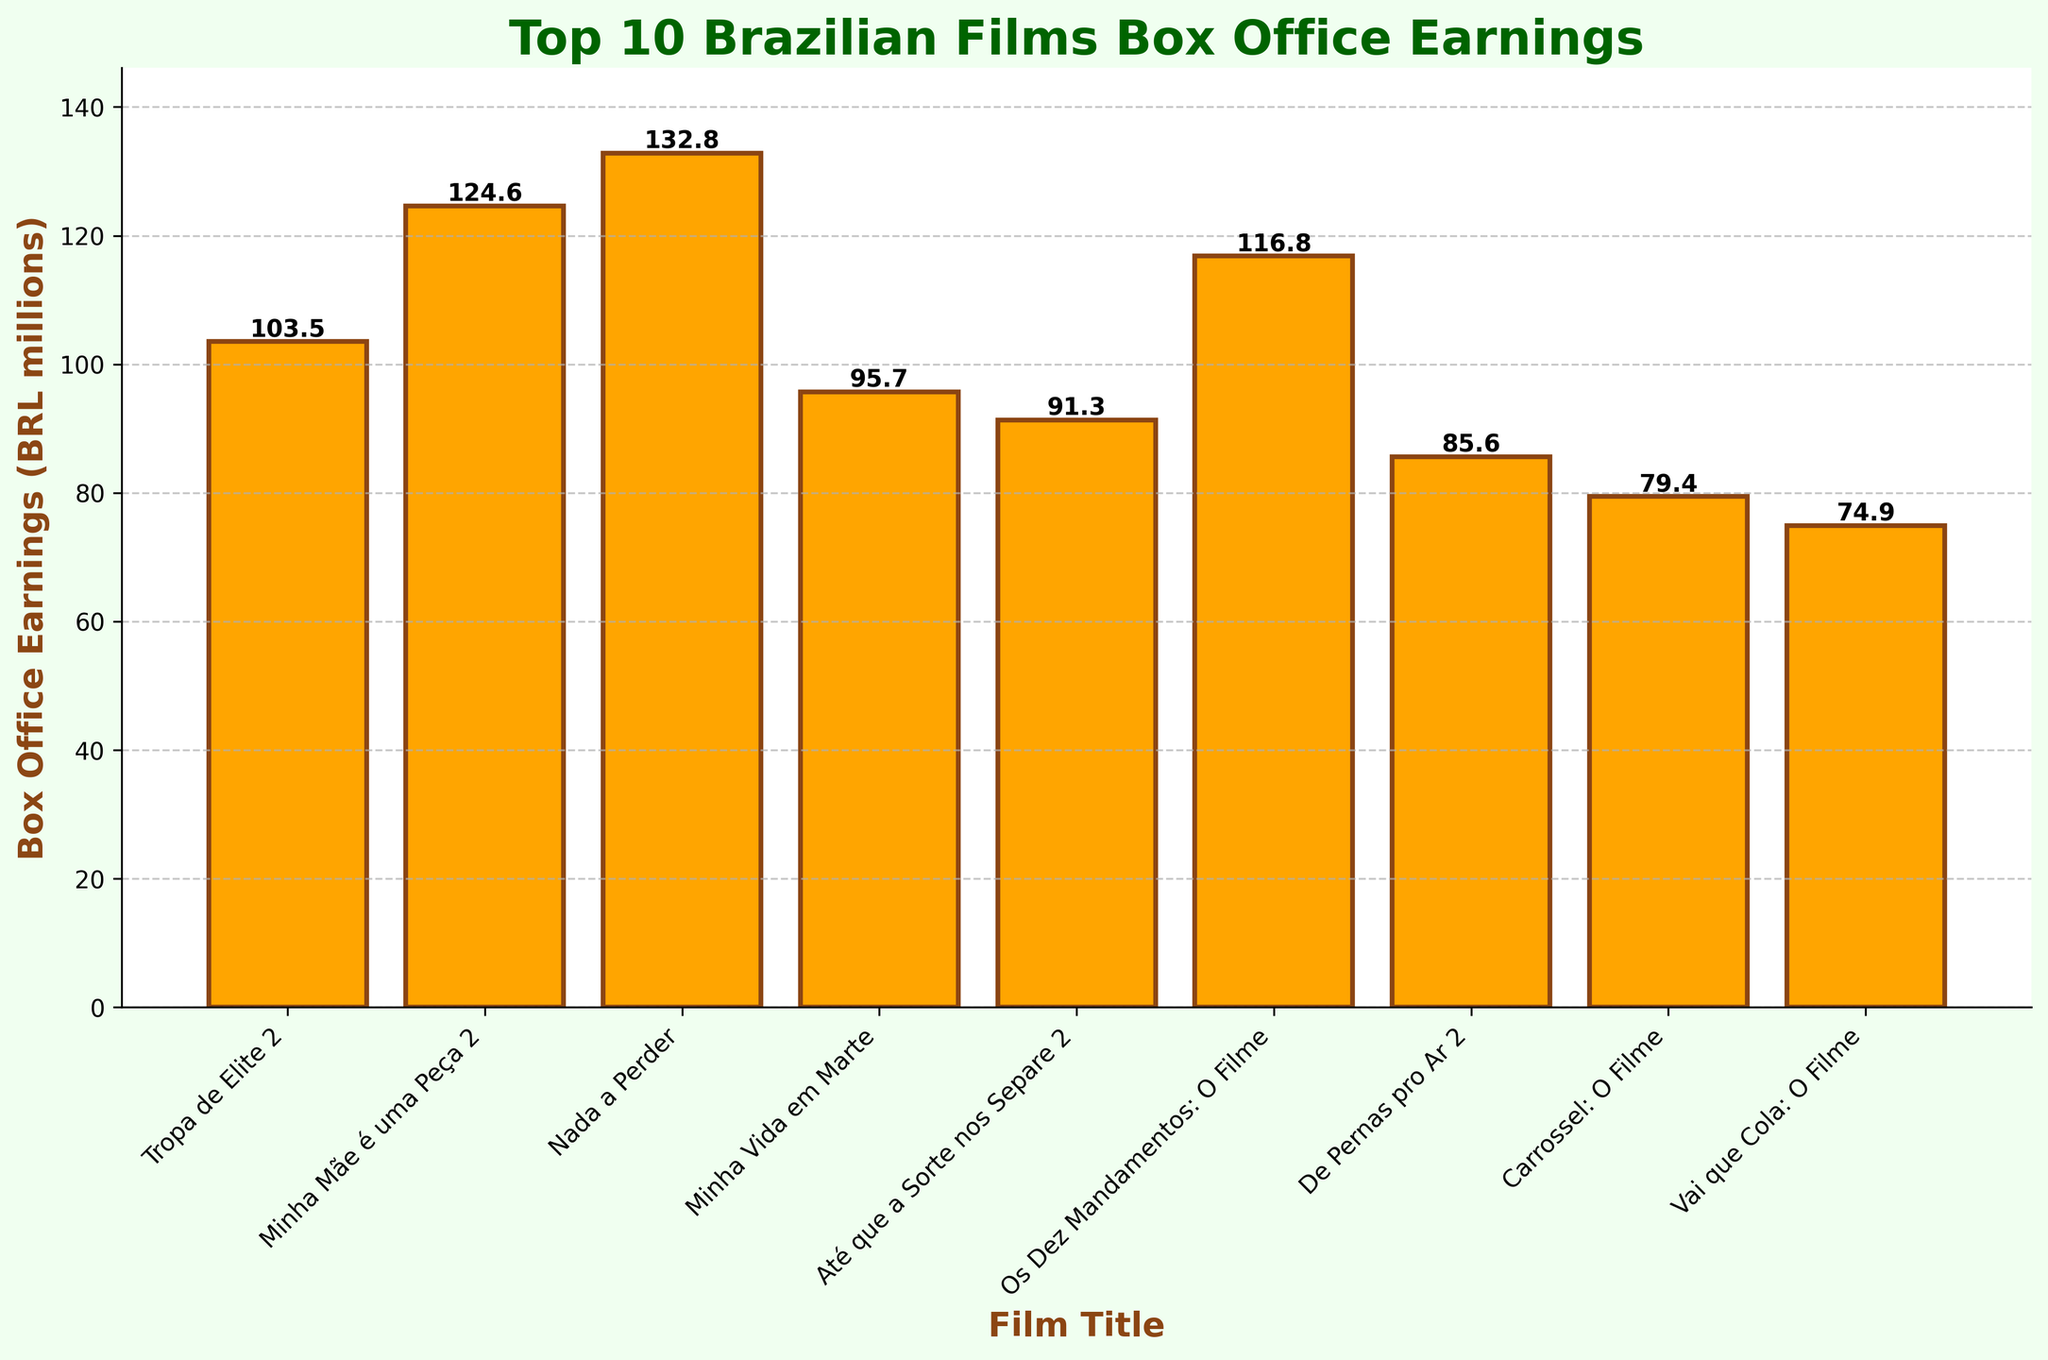Which film had the highest box office earnings? The film with the highest bar corresponds to "Nada a Perder" with box office earnings of 132.8 million BRL.
Answer: Nada a Perder Which film had the lowest box office earnings? The film with the lowest bar corresponds to "Vai que Cola: O Filme" with box office earnings of 74.9 million BRL.
Answer: Vai que Cola: O Filme What's the difference in box office earnings between "Minha Mãe é uma Peça 2" and "Os Dez Mandamentos: O Filme"? The box office earnings of "Minha Mãe é uma Peça 2" is 124.6 million BRL, and for "Os Dez Mandamentos: O Filme" it is 116.8 million BRL. The difference is 124.6 - 116.8 = 7.8 million BRL.
Answer: 7.8 million BRL Which films have earnings greater than 100 million BRL? By looking at the heights of the bars, "Minha Mãe é uma Peça 2" (124.6 million BRL), "Nada a Perder" (132.8 million BRL), and "Tropa de Elite 2" (103.5 million BRL) have earnings greater than 100 million BRL.
Answer: Minha Mãe é uma Peça 2, Nada a Perder, Tropa de Elite 2 What's the average box office earnings of the top 3 films? The top 3 films by earnings are "Nada a Perder" (132.8 million BRL), "Minha Mãe é uma Peça 2" (124.6 million BRL), and "Os Dez Mandamentos: O Filme" (116.8 million BRL). The average is (132.8 + 124.6 + 116.8) / 3 = 124.7 million BRL.
Answer: 124.7 million BRL What is the sum of the box office earnings for the films "De Pernas pro Ar 2" and "Carrossel: O Filme"? The box office earnings for "De Pernas pro Ar 2" is 85.6 million BRL and for "Carrossel: O Filme" is 79.4 million BRL. The sum is 85.6 + 79.4 = 165 million BRL.
Answer: 165 million BRL How many films have earnings between 80 and 90 million BRL? By observing the bar heights, the films "Até que a Sorte nos Separe 2" (91.3 million BRL), "De Pernas pro Ar 2" (85.6 million BRL), and "Carrossel: O Filme" (79.4 million BRL) are within this range, but only "De Pernas pro Ar 2" and "Carrossel: O Filme" correctly fall between 80 and 90 million BRL.
Answer: 2 Which films have earnings closest to each other? By comparing adjacent bar heights, "De Pernas pro Ar 2" (85.6 million BRL) and "Até que a Sorte nos Separe 2" (91.3 million BRL) have earnings that are very close with a difference of 91.3 - 85.6 = 5.7 million BRL.
Answer: De Pernas pro Ar 2 and Até que a Sorte nos Separe 2 